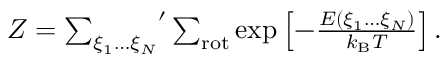Convert formula to latex. <formula><loc_0><loc_0><loc_500><loc_500>\begin{array} { r } { Z = { \sum _ { \xi _ { 1 } \dots \xi _ { N } } } ^ { \prime } \sum _ { r o t } \exp \left [ - \frac { E ( \xi _ { 1 } \dots \xi _ { N } ) } { k _ { B } T } \right ] . } \end{array}</formula> 